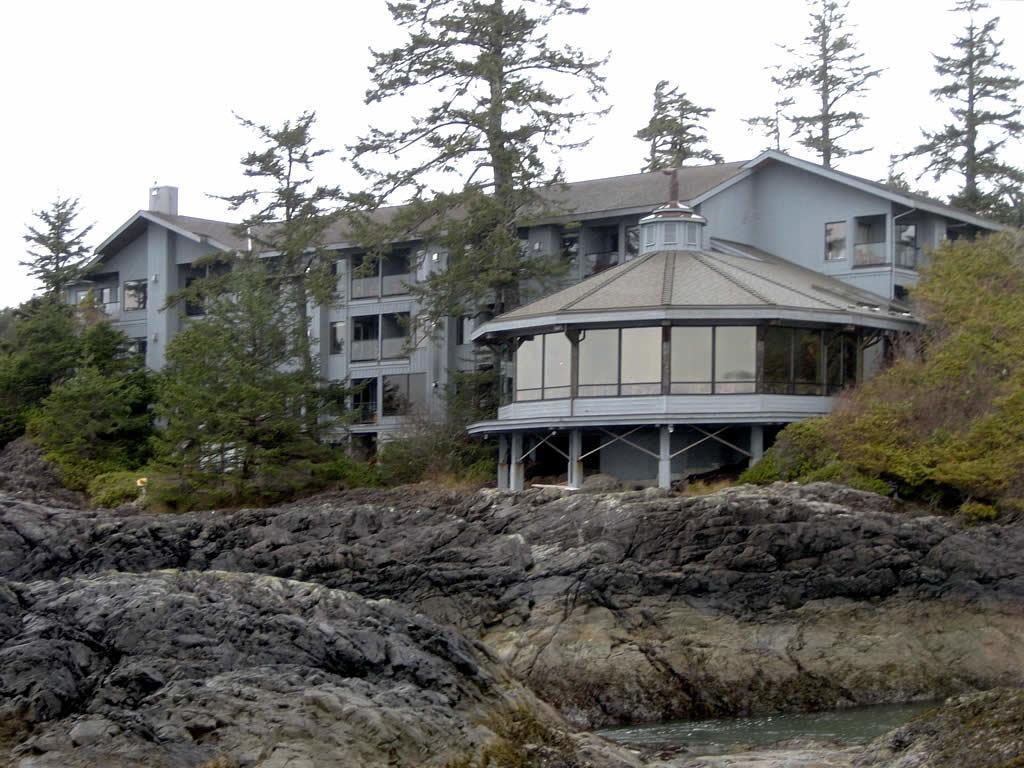Could you give a brief overview of what you see in this image? In this image, we can see a building, walls, glass objects, pillars, trees and plants. At the bottom, we can see rocks and water. Background we can see the sky. 